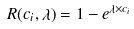Convert formula to latex. <formula><loc_0><loc_0><loc_500><loc_500>R ( c _ { i } , \lambda ) = 1 - e ^ { \lambda \times c _ { i } }</formula> 